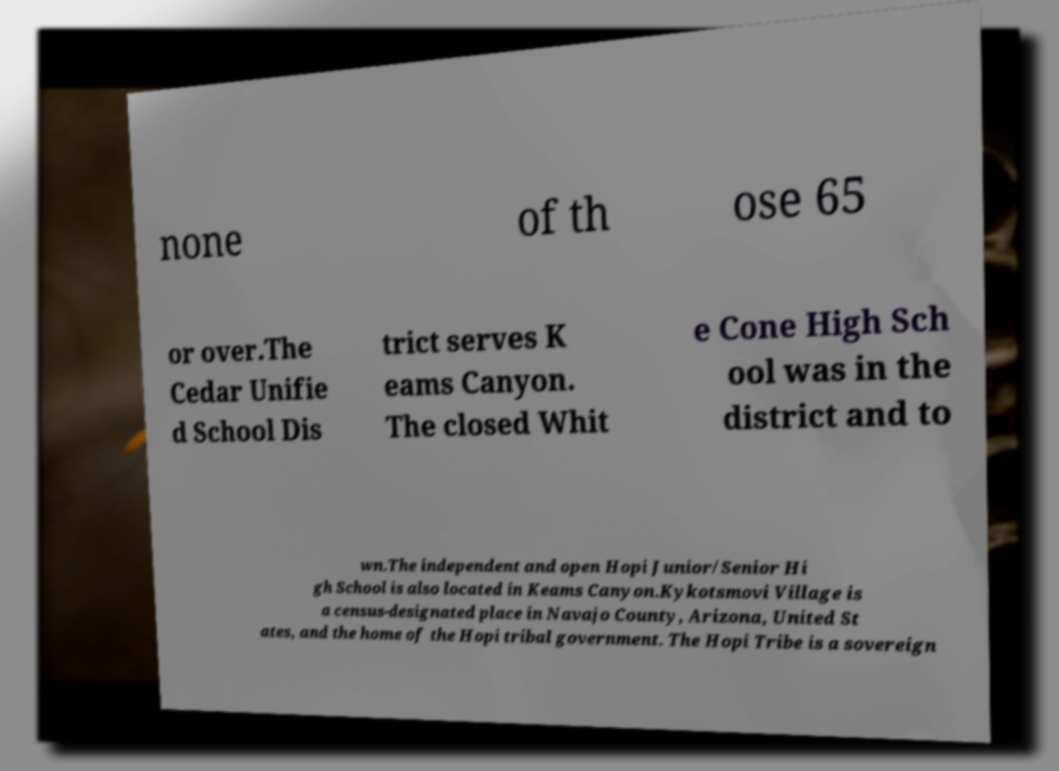I need the written content from this picture converted into text. Can you do that? none of th ose 65 or over.The Cedar Unifie d School Dis trict serves K eams Canyon. The closed Whit e Cone High Sch ool was in the district and to wn.The independent and open Hopi Junior/Senior Hi gh School is also located in Keams Canyon.Kykotsmovi Village is a census-designated place in Navajo County, Arizona, United St ates, and the home of the Hopi tribal government. The Hopi Tribe is a sovereign 